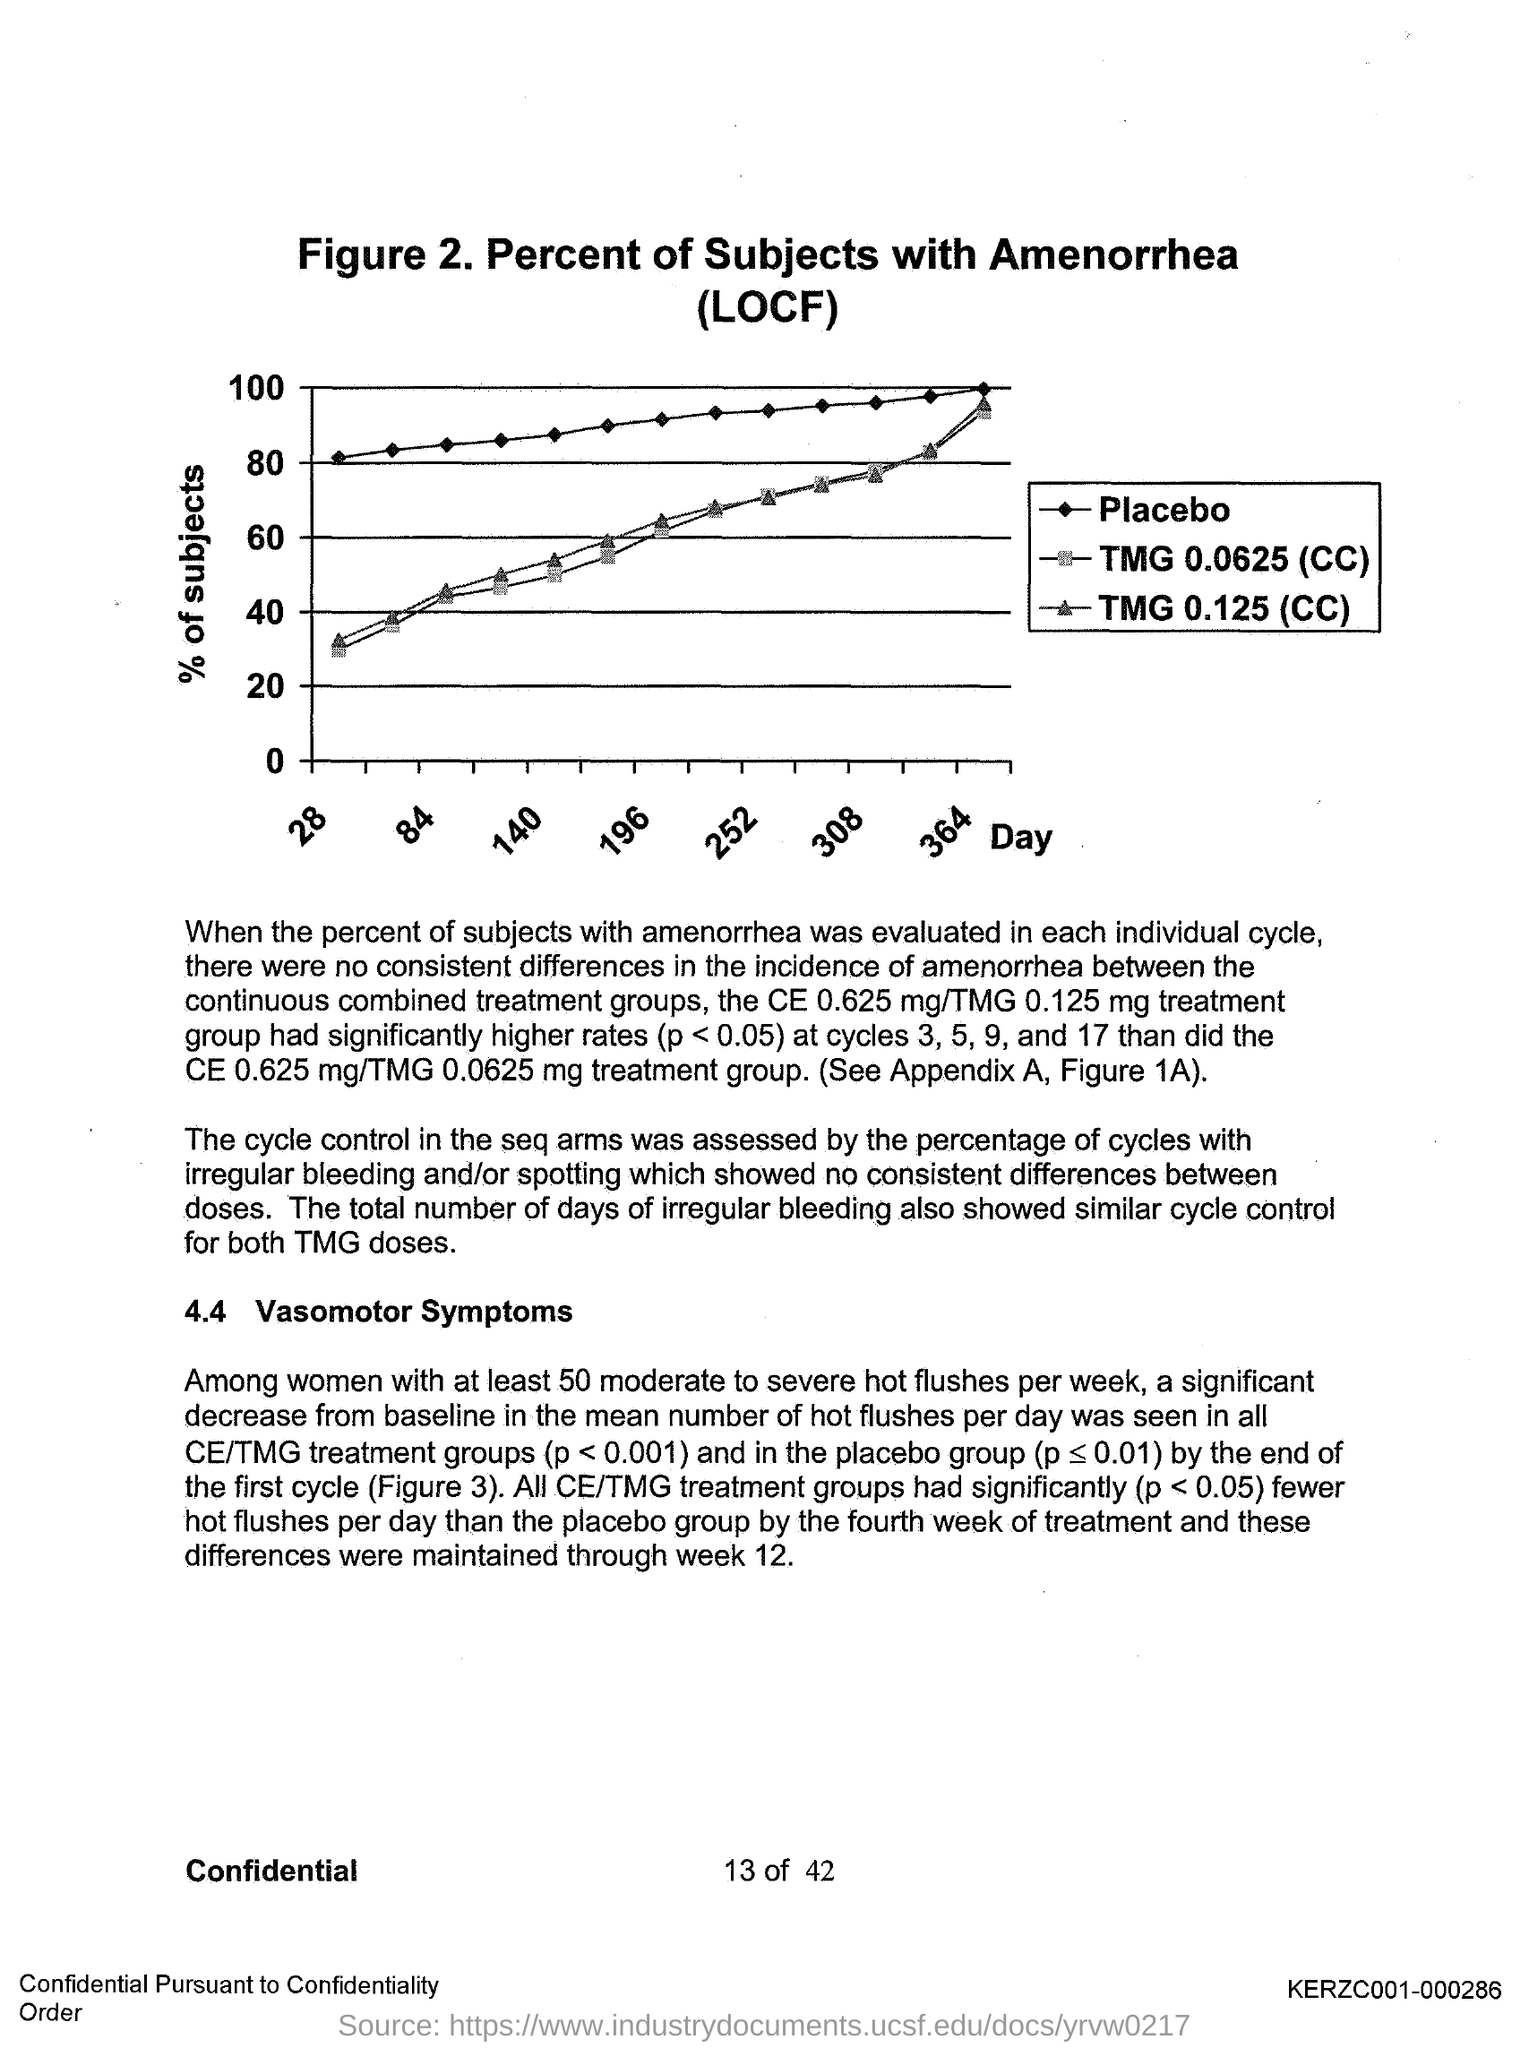Mention a couple of crucial points in this snapshot. The y-axis represents the percentage of subjects who exhibited a certain behavior or response in a study. The x-axis in the graph shows the day of the week, where the days of the week are plotted in a chronological order, starting from Sunday and ending with Saturday. The figure number is 2. 